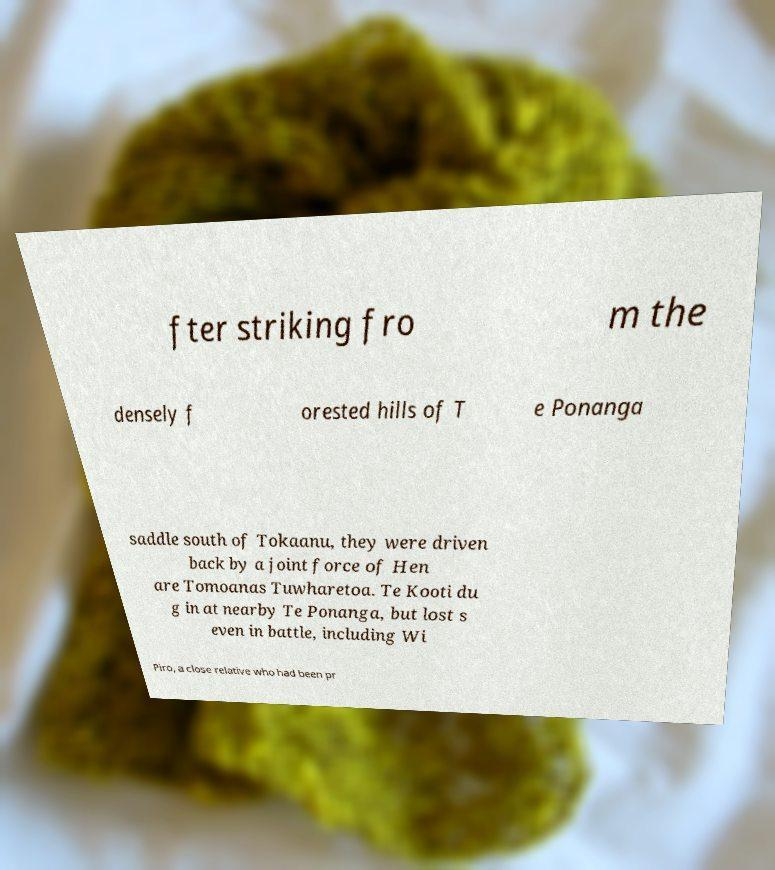For documentation purposes, I need the text within this image transcribed. Could you provide that? fter striking fro m the densely f orested hills of T e Ponanga saddle south of Tokaanu, they were driven back by a joint force of Hen are Tomoanas Tuwharetoa. Te Kooti du g in at nearby Te Ponanga, but lost s even in battle, including Wi Piro, a close relative who had been pr 